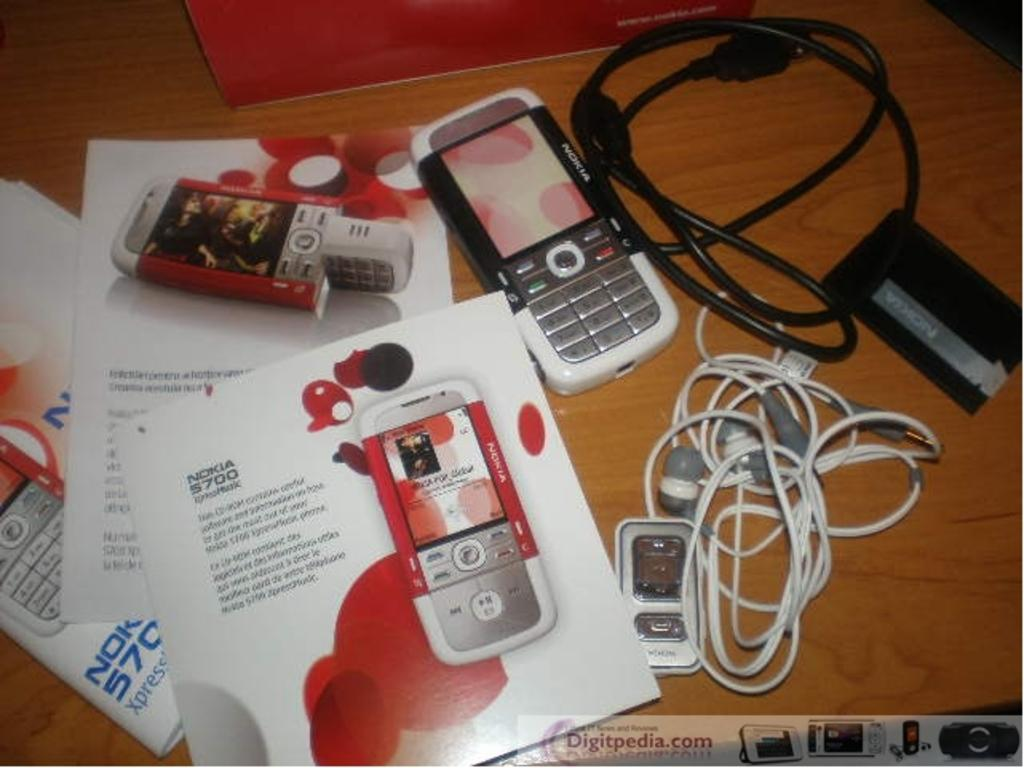<image>
Provide a brief description of the given image. The new Nokia phone has many different features and is in red and white. 